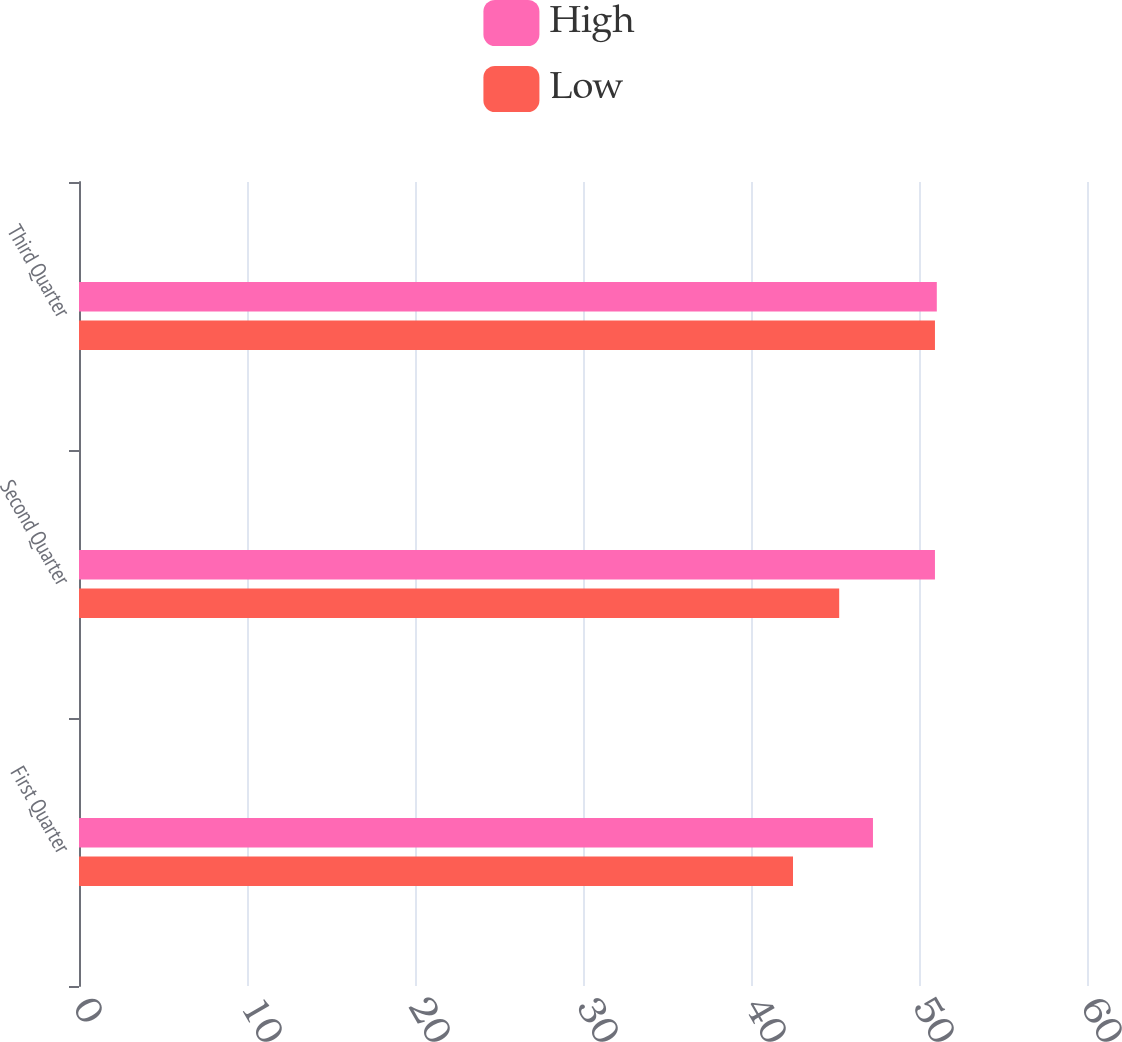<chart> <loc_0><loc_0><loc_500><loc_500><stacked_bar_chart><ecel><fcel>First Quarter<fcel>Second Quarter<fcel>Third Quarter<nl><fcel>High<fcel>47.26<fcel>50.95<fcel>51.06<nl><fcel>Low<fcel>42.5<fcel>45.25<fcel>50.95<nl></chart> 